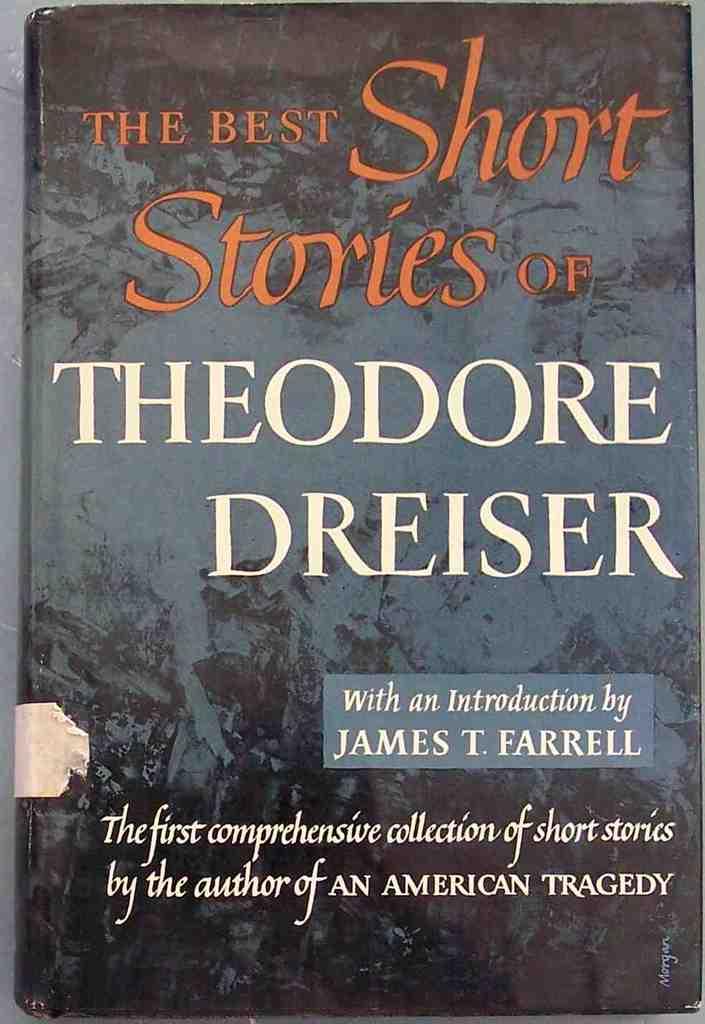Who wrote the book?
Give a very brief answer. Theodore dreiser. What is the name of this book?
Your response must be concise. The best short stories of theodore dreiser. 